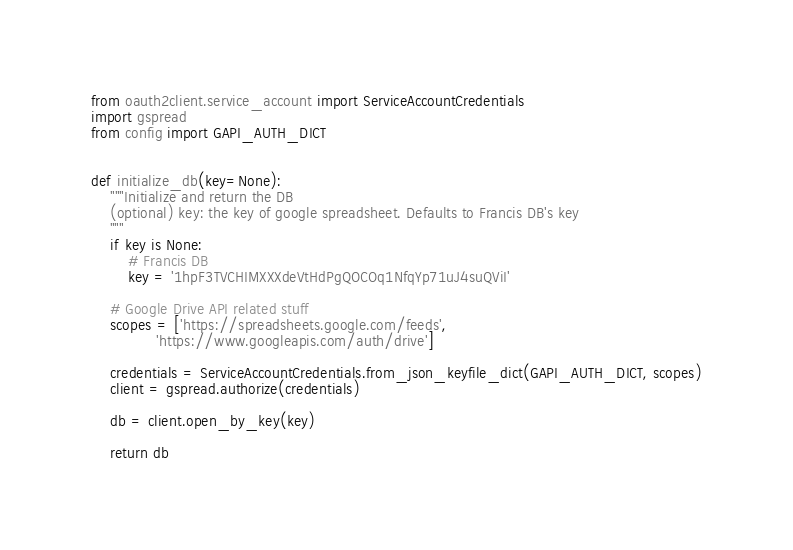<code> <loc_0><loc_0><loc_500><loc_500><_Python_>from oauth2client.service_account import ServiceAccountCredentials
import gspread
from config import GAPI_AUTH_DICT


def initialize_db(key=None):
    """Initialize and return the DB
    (optional) key: the key of google spreadsheet. Defaults to Francis DB's key
    """
    if key is None:
        # Francis DB
        key = '1hpF3TVCHIMXXXdeVtHdPgQOCOq1NfqYp71uJ4suQViI'

    # Google Drive API related stuff
    scopes = ['https://spreadsheets.google.com/feeds',
              'https://www.googleapis.com/auth/drive']

    credentials = ServiceAccountCredentials.from_json_keyfile_dict(GAPI_AUTH_DICT, scopes)
    client = gspread.authorize(credentials)

    db = client.open_by_key(key)

    return db
</code> 